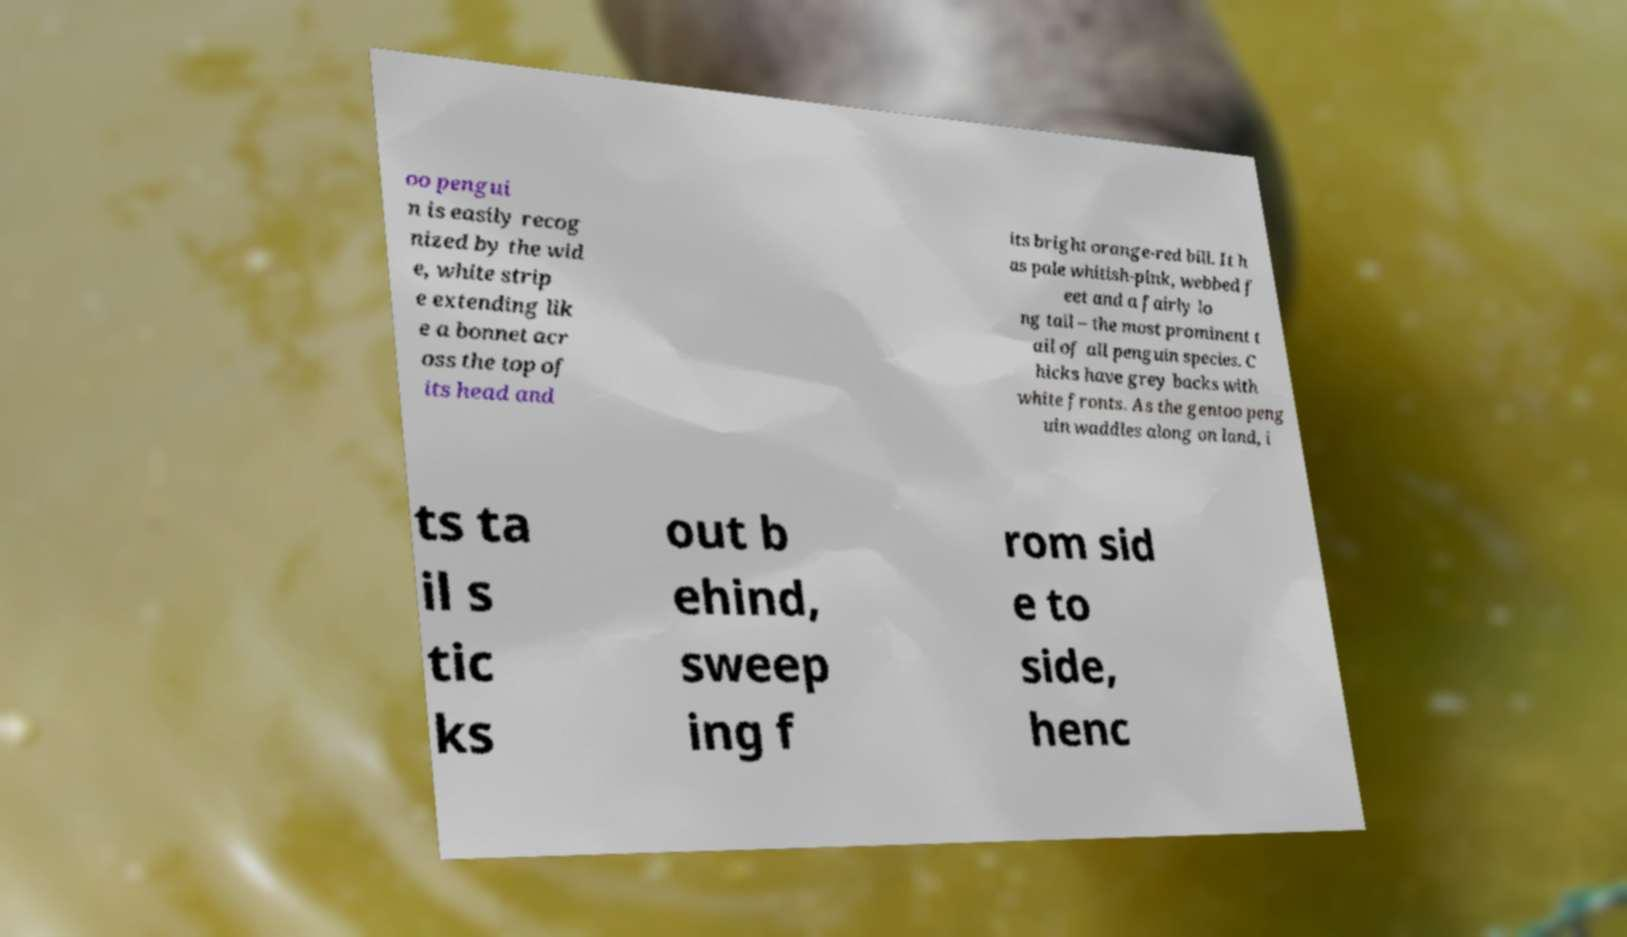Please read and relay the text visible in this image. What does it say? oo pengui n is easily recog nized by the wid e, white strip e extending lik e a bonnet acr oss the top of its head and its bright orange-red bill. It h as pale whitish-pink, webbed f eet and a fairly lo ng tail – the most prominent t ail of all penguin species. C hicks have grey backs with white fronts. As the gentoo peng uin waddles along on land, i ts ta il s tic ks out b ehind, sweep ing f rom sid e to side, henc 